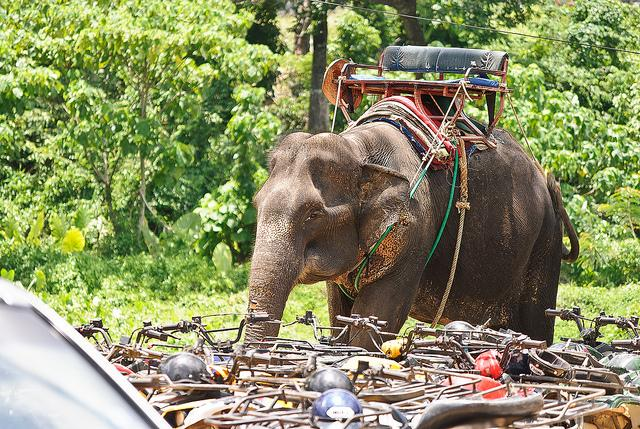What color is the back arch for the seat held by ropes on the back of this elephant? black 